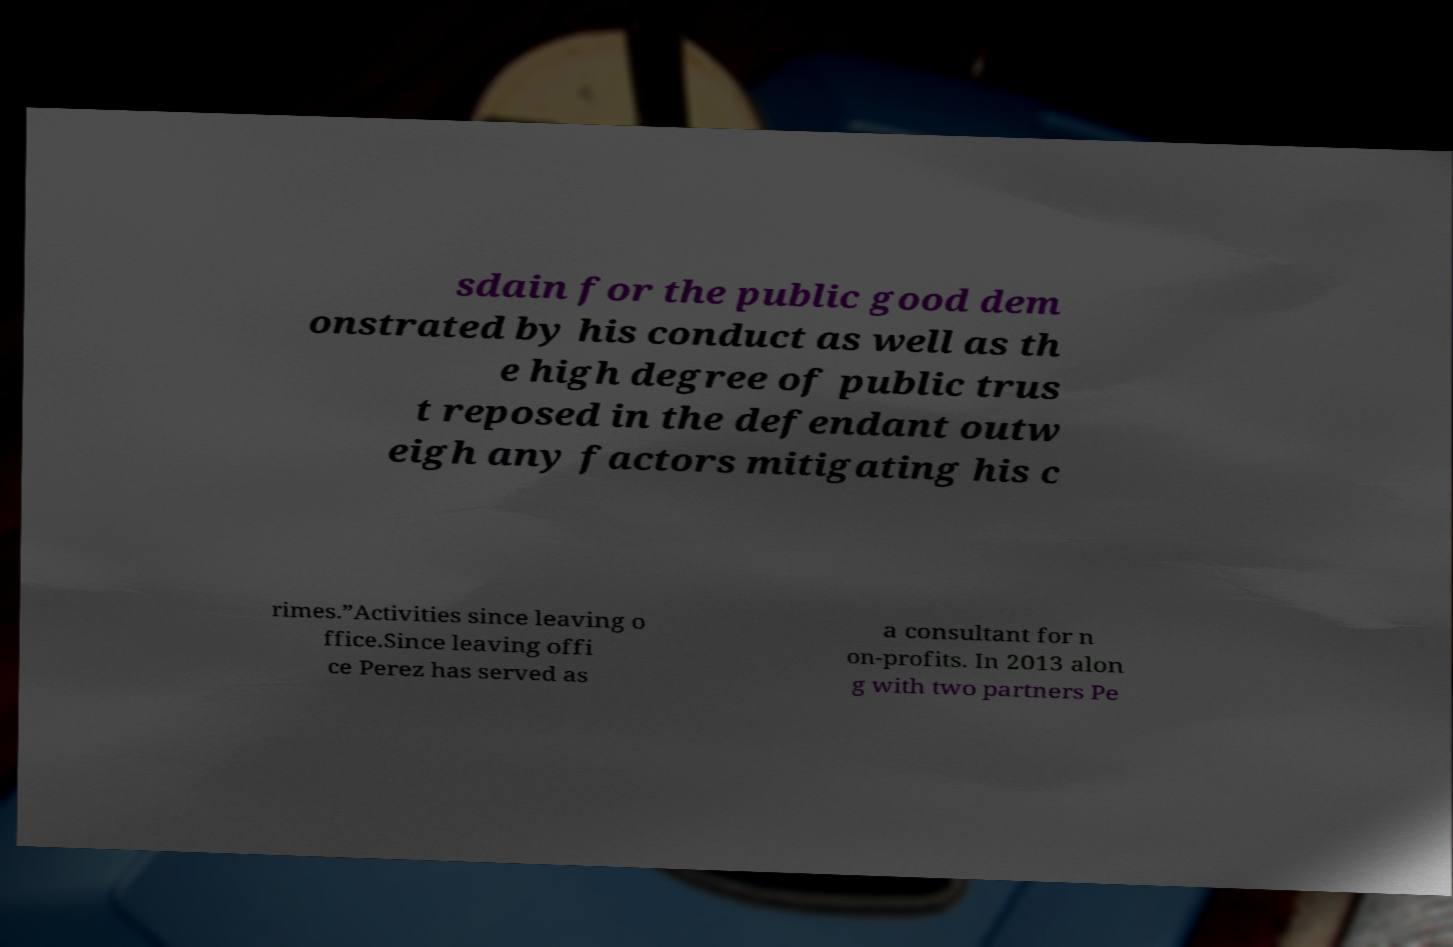Can you read and provide the text displayed in the image?This photo seems to have some interesting text. Can you extract and type it out for me? sdain for the public good dem onstrated by his conduct as well as th e high degree of public trus t reposed in the defendant outw eigh any factors mitigating his c rimes.”Activities since leaving o ffice.Since leaving offi ce Perez has served as a consultant for n on-profits. In 2013 alon g with two partners Pe 